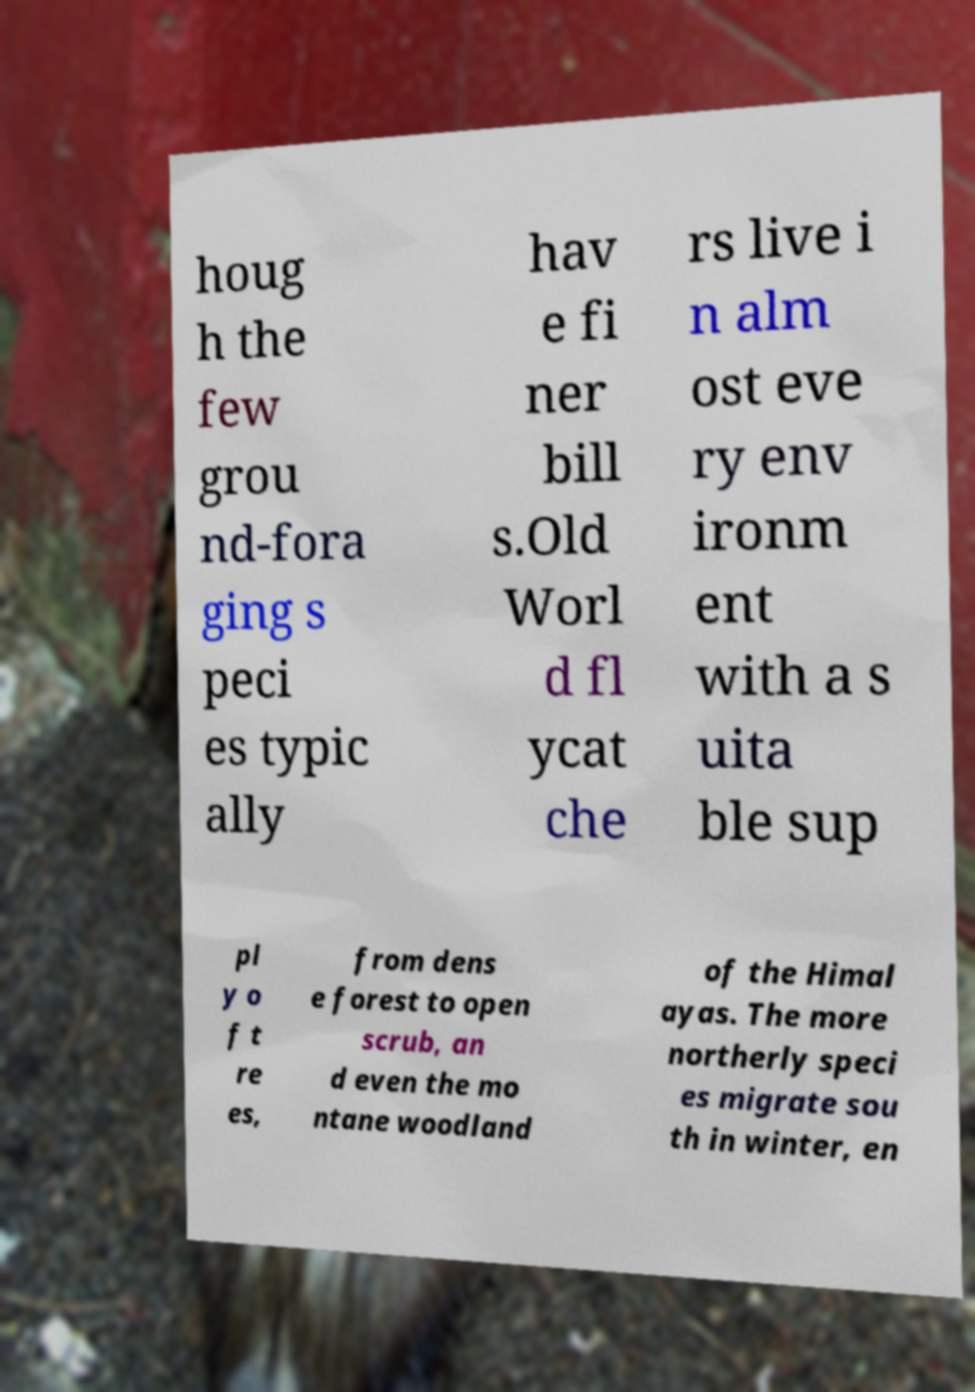Please read and relay the text visible in this image. What does it say? houg h the few grou nd-fora ging s peci es typic ally hav e fi ner bill s.Old Worl d fl ycat che rs live i n alm ost eve ry env ironm ent with a s uita ble sup pl y o f t re es, from dens e forest to open scrub, an d even the mo ntane woodland of the Himal ayas. The more northerly speci es migrate sou th in winter, en 